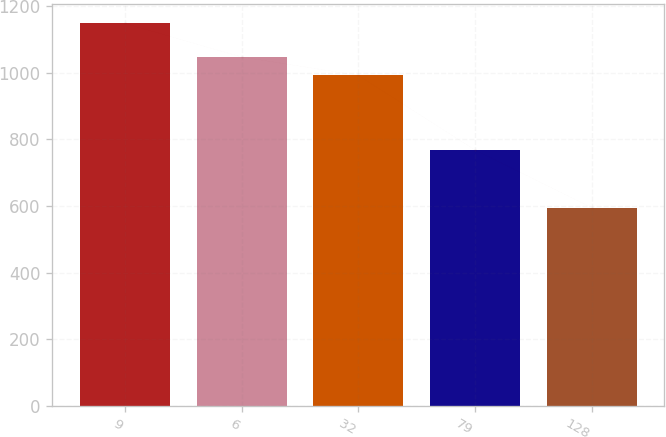Convert chart to OTSL. <chart><loc_0><loc_0><loc_500><loc_500><bar_chart><fcel>9<fcel>6<fcel>32<fcel>79<fcel>128<nl><fcel>1148<fcel>1047.3<fcel>992<fcel>768<fcel>595<nl></chart> 